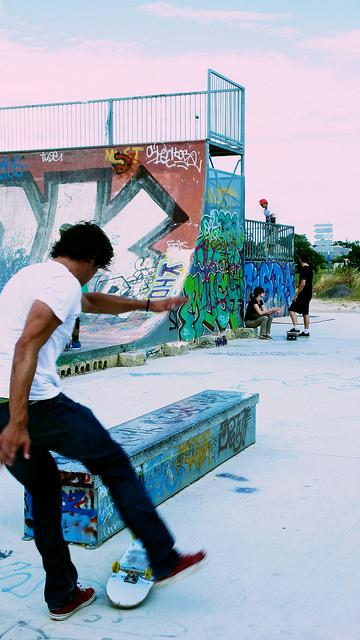What is the large ramp used for? skateboarding 